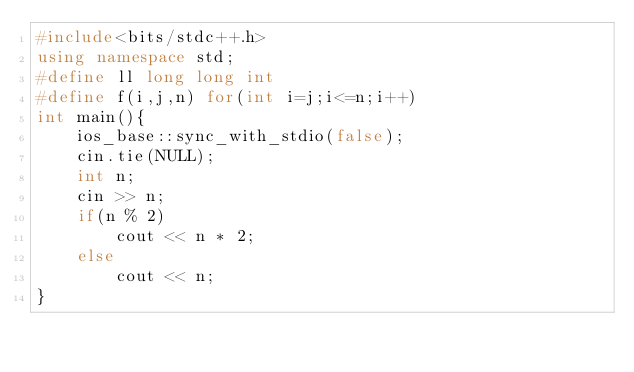Convert code to text. <code><loc_0><loc_0><loc_500><loc_500><_C++_>#include<bits/stdc++.h>
using namespace std;
#define ll long long int
#define f(i,j,n) for(int i=j;i<=n;i++)
int main(){
    ios_base::sync_with_stdio(false);
    cin.tie(NULL);
    int n;
    cin >> n;
    if(n % 2)
        cout << n * 2;
    else
        cout << n;
} 
</code> 